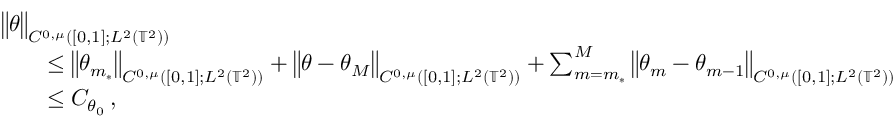<formula> <loc_0><loc_0><loc_500><loc_500>\begin{array} { r l } { { \left \| \theta \right \| _ { C ^ { 0 , \mu } ( [ 0 , 1 ] ; L ^ { 2 } ( { \mathbb { T } } ^ { 2 } ) ) } } \quad } \\ & { \leq \left \| \theta _ { m _ { * } } \right \| _ { C ^ { 0 , \mu } ( [ 0 , 1 ] ; L ^ { 2 } ( { \mathbb { T } } ^ { 2 } ) ) } + \left \| \theta - \theta _ { M } \right \| _ { C ^ { 0 , \mu } ( [ 0 , 1 ] ; L ^ { 2 } ( { \mathbb { T } } ^ { 2 } ) ) } + \sum _ { m = m _ { * } } ^ { M } \left \| \theta _ { m } - \theta _ { m - 1 } \right \| _ { C ^ { 0 , \mu } ( [ 0 , 1 ] ; L ^ { 2 } ( { \mathbb { T } } ^ { 2 } ) ) } } \\ & { \leq C _ { \theta _ { 0 } } \, , } \end{array}</formula> 